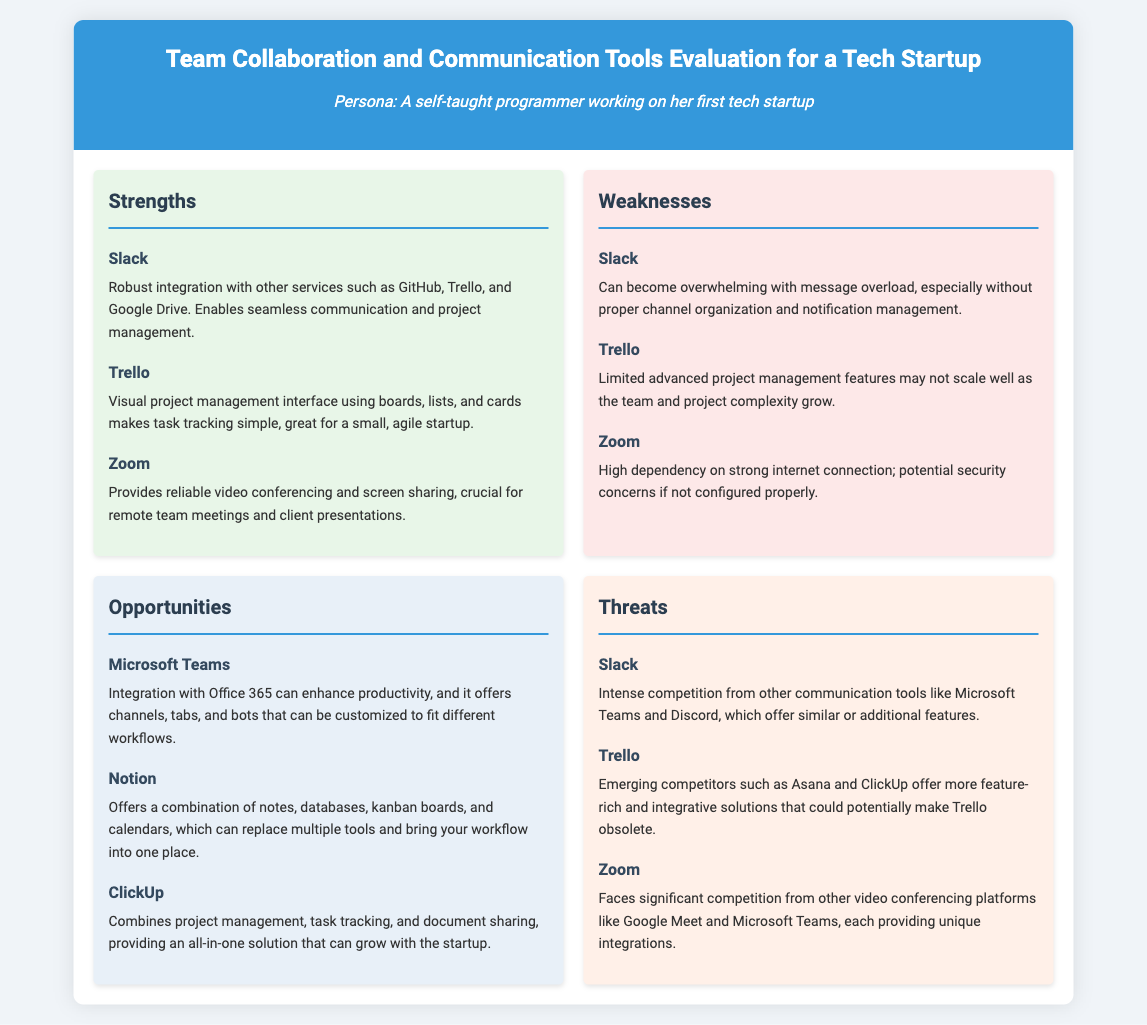What is a strength of Slack? The strength of Slack is its robust integration with other services such as GitHub, Trello, and Google Drive.
Answer: Robust integration with other services What is a weakness of Trello? The weakness of Trello is that it has limited advanced project management features which may not scale well.
Answer: Limited advanced project management features Which tool offers integration with Office 365? The tool that offers integration with Office 365 is Microsoft Teams.
Answer: Microsoft Teams What threat does Zoom face? Zoom faces significant competition from other video conferencing platforms like Google Meet and Microsoft Teams.
Answer: Competition from other video conferencing platforms How many strengths are listed for the tools? There are three strengths listed for the tools in the document.
Answer: Three What is an opportunity mentioned for Notion? An opportunity for Notion is that it offers a combination of notes, databases, kanban boards, and calendars.
Answer: Combination of notes, databases, kanban boards, and calendars Which tool is noted for its video conferencing? The tool noted for its video conferencing is Zoom.
Answer: Zoom What color represents weaknesses in the SWOT analysis? The color that represents weaknesses in the SWOT analysis is light red.
Answer: Light red 